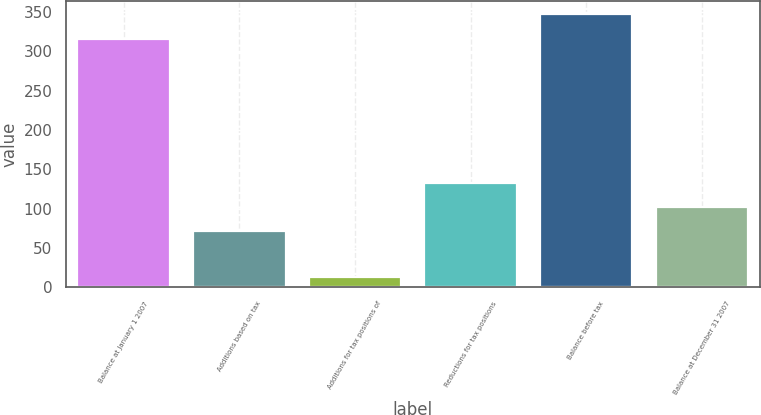Convert chart. <chart><loc_0><loc_0><loc_500><loc_500><bar_chart><fcel>Balance at January 1 2007<fcel>Additions based on tax<fcel>Additions for tax positions of<fcel>Reductions for tax positions<fcel>Balance before tax<fcel>Balance at December 31 2007<nl><fcel>316<fcel>71<fcel>13<fcel>132.4<fcel>346.7<fcel>101.7<nl></chart> 